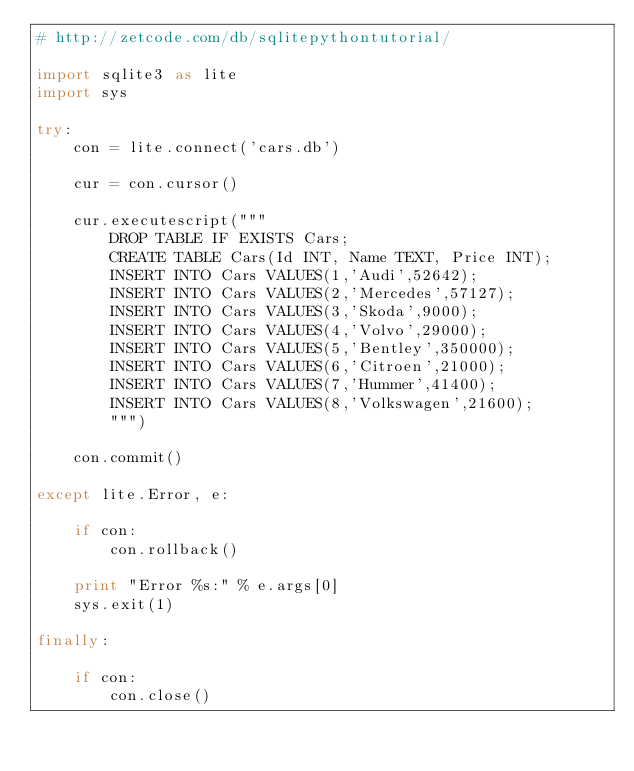<code> <loc_0><loc_0><loc_500><loc_500><_Python_># http://zetcode.com/db/sqlitepythontutorial/

import sqlite3 as lite
import sys

try:
    con = lite.connect('cars.db')

    cur = con.cursor()  

    cur.executescript("""
        DROP TABLE IF EXISTS Cars;
        CREATE TABLE Cars(Id INT, Name TEXT, Price INT);
        INSERT INTO Cars VALUES(1,'Audi',52642);
        INSERT INTO Cars VALUES(2,'Mercedes',57127);
        INSERT INTO Cars VALUES(3,'Skoda',9000);
        INSERT INTO Cars VALUES(4,'Volvo',29000);
        INSERT INTO Cars VALUES(5,'Bentley',350000);
        INSERT INTO Cars VALUES(6,'Citroen',21000);
        INSERT INTO Cars VALUES(7,'Hummer',41400);
        INSERT INTO Cars VALUES(8,'Volkswagen',21600);
        """)

    con.commit()
    
except lite.Error, e:
    
    if con:
        con.rollback()
        
    print "Error %s:" % e.args[0]
    sys.exit(1)
    
finally:
    
    if con:
        con.close() </code> 